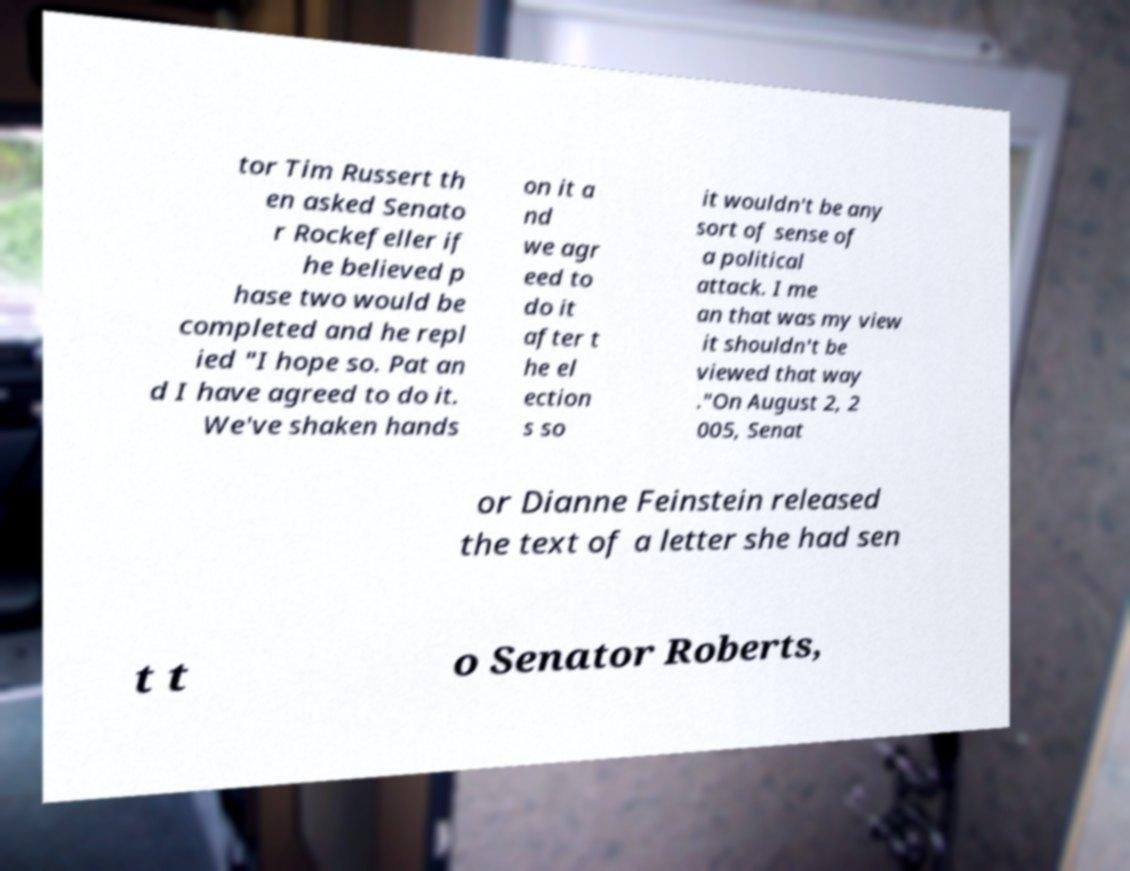Can you read and provide the text displayed in the image?This photo seems to have some interesting text. Can you extract and type it out for me? tor Tim Russert th en asked Senato r Rockefeller if he believed p hase two would be completed and he repl ied "I hope so. Pat an d I have agreed to do it. We've shaken hands on it a nd we agr eed to do it after t he el ection s so it wouldn't be any sort of sense of a political attack. I me an that was my view it shouldn't be viewed that way ."On August 2, 2 005, Senat or Dianne Feinstein released the text of a letter she had sen t t o Senator Roberts, 